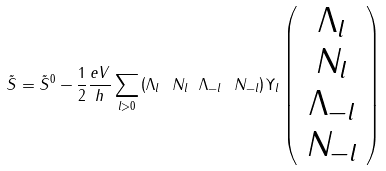<formula> <loc_0><loc_0><loc_500><loc_500>\tilde { S } = \tilde { S } ^ { 0 } - \frac { 1 } { 2 } \frac { e V } { h } \sum _ { l > 0 } \left ( \Lambda _ { l } \ N _ { l } \ \Lambda _ { - l } \ N _ { - l } \right ) \Upsilon _ { l } \left ( \begin{array} { c } \Lambda _ { l } \\ N _ { l } \\ \Lambda _ { - l } \\ N _ { - l } \end{array} \right )</formula> 